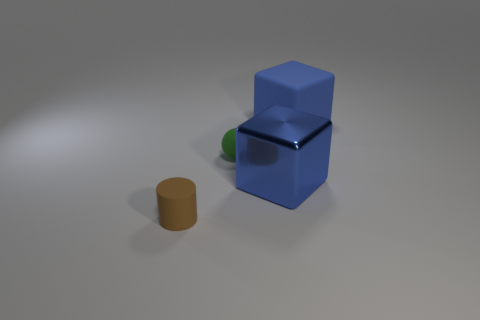Add 4 small yellow shiny spheres. How many objects exist? 8 Subtract all blue things. Subtract all blocks. How many objects are left? 0 Add 3 big shiny cubes. How many big shiny cubes are left? 4 Add 2 big blue rubber objects. How many big blue rubber objects exist? 3 Subtract 0 gray blocks. How many objects are left? 4 Subtract all spheres. How many objects are left? 3 Subtract all gray balls. Subtract all purple blocks. How many balls are left? 1 